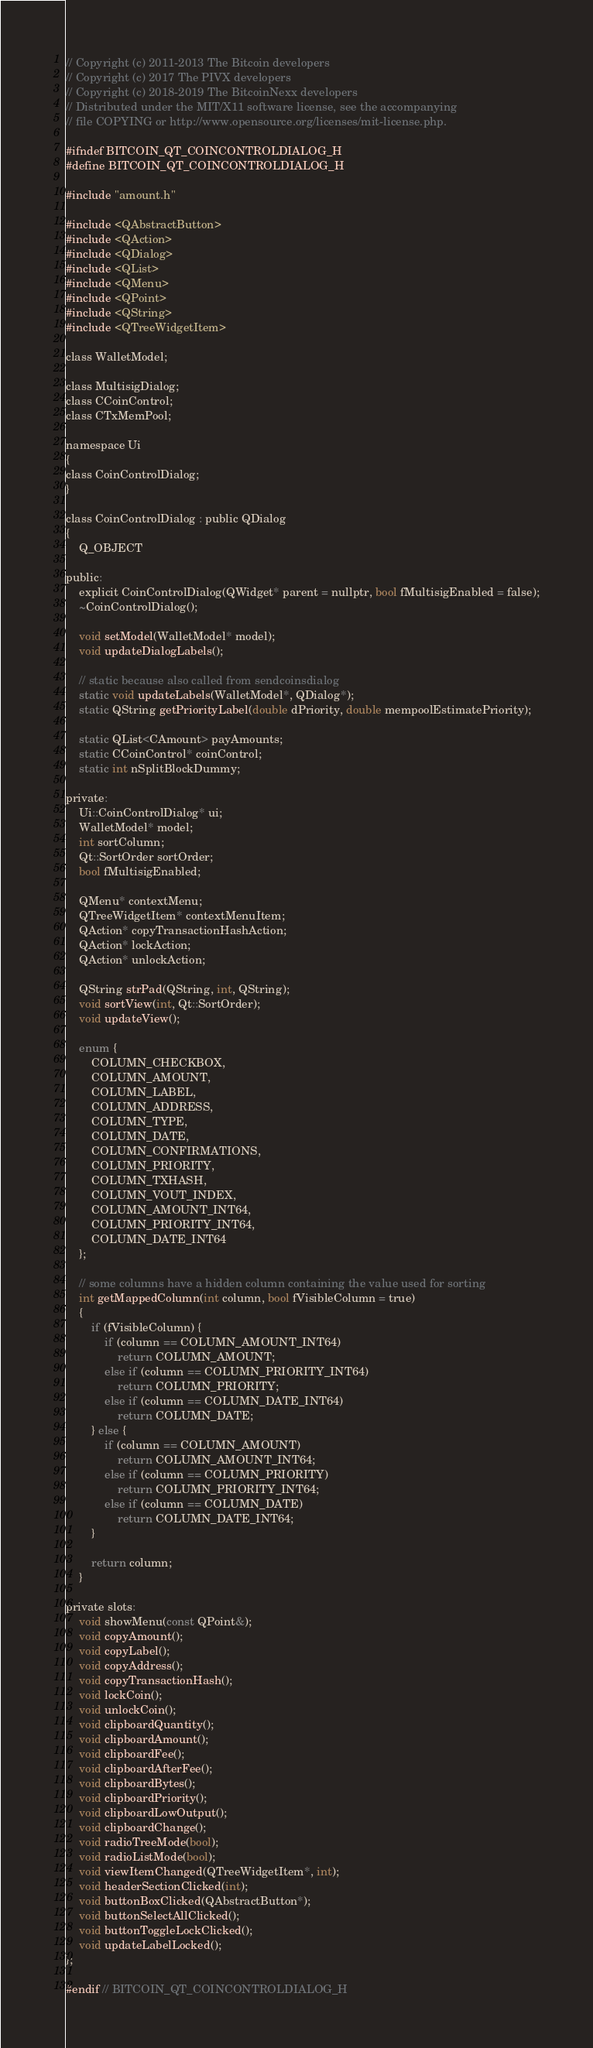<code> <loc_0><loc_0><loc_500><loc_500><_C_>// Copyright (c) 2011-2013 The Bitcoin developers
// Copyright (c) 2017 The PIVX developers
// Copyright (c) 2018-2019 The BitcoinNexx developers
// Distributed under the MIT/X11 software license, see the accompanying
// file COPYING or http://www.opensource.org/licenses/mit-license.php.

#ifndef BITCOIN_QT_COINCONTROLDIALOG_H
#define BITCOIN_QT_COINCONTROLDIALOG_H

#include "amount.h"

#include <QAbstractButton>
#include <QAction>
#include <QDialog>
#include <QList>
#include <QMenu>
#include <QPoint>
#include <QString>
#include <QTreeWidgetItem>

class WalletModel;

class MultisigDialog;
class CCoinControl;
class CTxMemPool;

namespace Ui
{
class CoinControlDialog;
}

class CoinControlDialog : public QDialog
{
    Q_OBJECT

public:
    explicit CoinControlDialog(QWidget* parent = nullptr, bool fMultisigEnabled = false);
    ~CoinControlDialog();

    void setModel(WalletModel* model);
    void updateDialogLabels();

    // static because also called from sendcoinsdialog
    static void updateLabels(WalletModel*, QDialog*);
    static QString getPriorityLabel(double dPriority, double mempoolEstimatePriority);

    static QList<CAmount> payAmounts;
    static CCoinControl* coinControl;
    static int nSplitBlockDummy;

private:
    Ui::CoinControlDialog* ui;
    WalletModel* model;
    int sortColumn;
    Qt::SortOrder sortOrder;
    bool fMultisigEnabled;

    QMenu* contextMenu;
    QTreeWidgetItem* contextMenuItem;
    QAction* copyTransactionHashAction;
    QAction* lockAction;
    QAction* unlockAction;

    QString strPad(QString, int, QString);
    void sortView(int, Qt::SortOrder);
    void updateView();

    enum {
        COLUMN_CHECKBOX,
        COLUMN_AMOUNT,
        COLUMN_LABEL,
        COLUMN_ADDRESS,
        COLUMN_TYPE,
        COLUMN_DATE,
        COLUMN_CONFIRMATIONS,
        COLUMN_PRIORITY,
        COLUMN_TXHASH,
        COLUMN_VOUT_INDEX,
        COLUMN_AMOUNT_INT64,
        COLUMN_PRIORITY_INT64,
        COLUMN_DATE_INT64
    };

    // some columns have a hidden column containing the value used for sorting
    int getMappedColumn(int column, bool fVisibleColumn = true)
    {
        if (fVisibleColumn) {
            if (column == COLUMN_AMOUNT_INT64)
                return COLUMN_AMOUNT;
            else if (column == COLUMN_PRIORITY_INT64)
                return COLUMN_PRIORITY;
            else if (column == COLUMN_DATE_INT64)
                return COLUMN_DATE;
        } else {
            if (column == COLUMN_AMOUNT)
                return COLUMN_AMOUNT_INT64;
            else if (column == COLUMN_PRIORITY)
                return COLUMN_PRIORITY_INT64;
            else if (column == COLUMN_DATE)
                return COLUMN_DATE_INT64;
        }

        return column;
    }

private slots:
    void showMenu(const QPoint&);
    void copyAmount();
    void copyLabel();
    void copyAddress();
    void copyTransactionHash();
    void lockCoin();
    void unlockCoin();
    void clipboardQuantity();
    void clipboardAmount();
    void clipboardFee();
    void clipboardAfterFee();
    void clipboardBytes();
    void clipboardPriority();
    void clipboardLowOutput();
    void clipboardChange();
    void radioTreeMode(bool);
    void radioListMode(bool);
    void viewItemChanged(QTreeWidgetItem*, int);
    void headerSectionClicked(int);
    void buttonBoxClicked(QAbstractButton*);
    void buttonSelectAllClicked();
    void buttonToggleLockClicked();
    void updateLabelLocked();
};

#endif // BITCOIN_QT_COINCONTROLDIALOG_H
</code> 